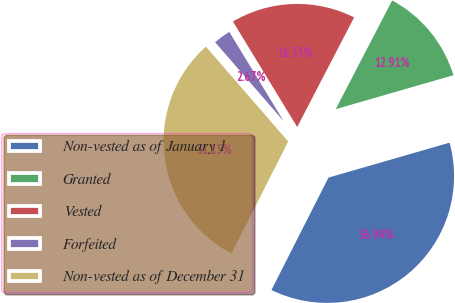Convert chart. <chart><loc_0><loc_0><loc_500><loc_500><pie_chart><fcel>Non-vested as of January 1<fcel>Granted<fcel>Vested<fcel>Forfeited<fcel>Non-vested as of December 31<nl><fcel>36.94%<fcel>12.91%<fcel>16.33%<fcel>2.67%<fcel>31.15%<nl></chart> 